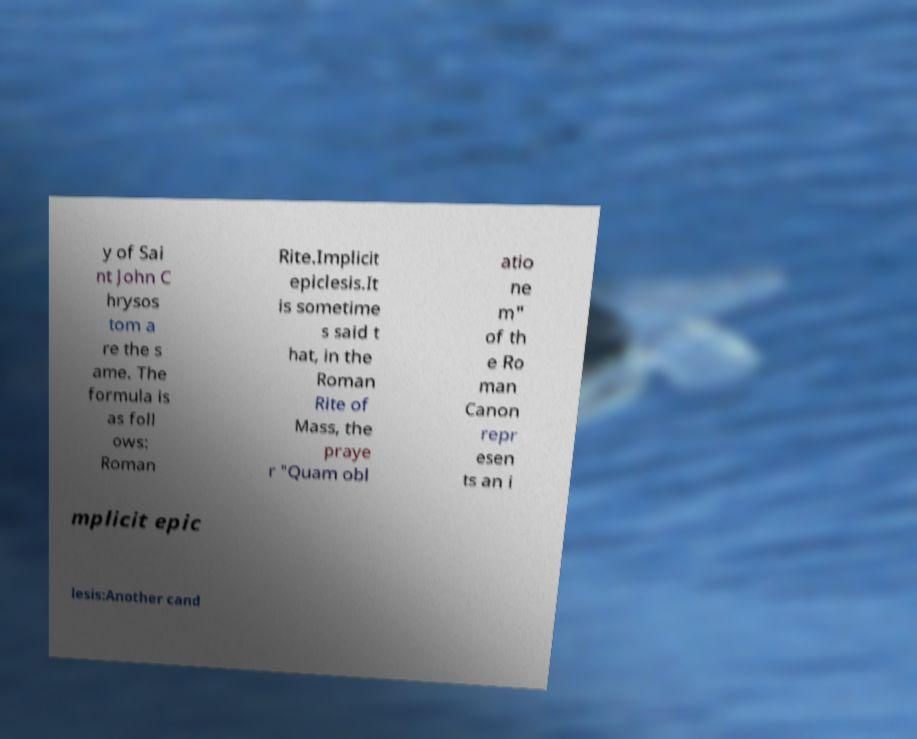Could you extract and type out the text from this image? y of Sai nt John C hrysos tom a re the s ame. The formula is as foll ows: Roman Rite.Implicit epiclesis.It is sometime s said t hat, in the Roman Rite of Mass, the praye r "Quam obl atio ne m" of th e Ro man Canon repr esen ts an i mplicit epic lesis:Another cand 